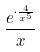<formula> <loc_0><loc_0><loc_500><loc_500>\frac { e ^ { \cdot \frac { 4 } { x ^ { 5 } } } } { x }</formula> 